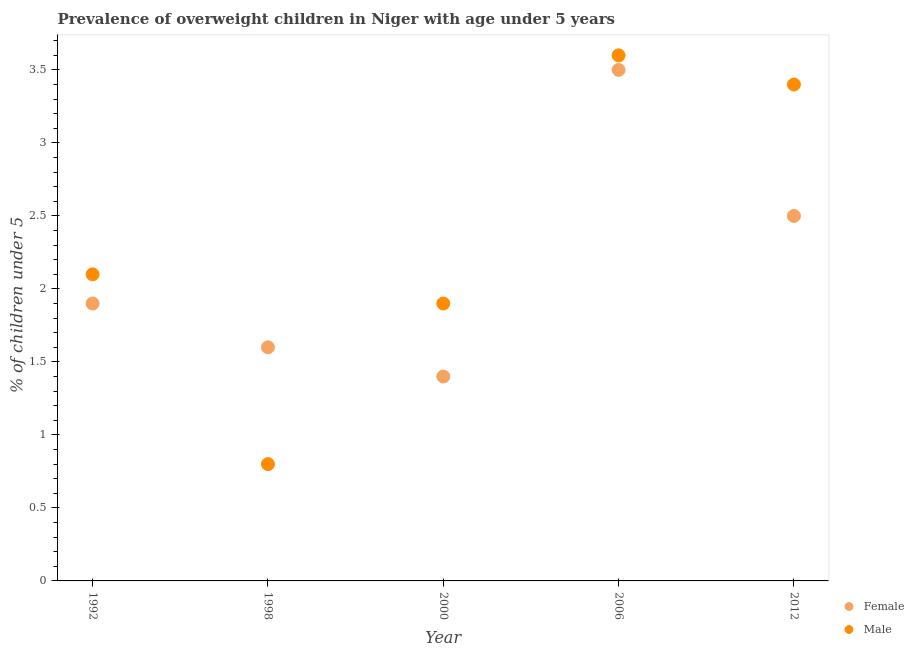Is the number of dotlines equal to the number of legend labels?
Your answer should be very brief. Yes. What is the percentage of obese female children in 1992?
Your answer should be compact. 1.9. Across all years, what is the minimum percentage of obese male children?
Offer a terse response. 0.8. In which year was the percentage of obese male children minimum?
Provide a short and direct response. 1998. What is the total percentage of obese female children in the graph?
Your answer should be very brief. 10.9. What is the difference between the percentage of obese female children in 1992 and that in 2000?
Give a very brief answer. 0.5. What is the difference between the percentage of obese female children in 2006 and the percentage of obese male children in 2000?
Your response must be concise. 1.6. What is the average percentage of obese male children per year?
Offer a terse response. 2.36. In the year 2012, what is the difference between the percentage of obese male children and percentage of obese female children?
Your response must be concise. 0.9. What is the ratio of the percentage of obese female children in 1992 to that in 1998?
Ensure brevity in your answer.  1.19. Is the percentage of obese female children in 1992 less than that in 2006?
Ensure brevity in your answer.  Yes. Is the difference between the percentage of obese female children in 1992 and 1998 greater than the difference between the percentage of obese male children in 1992 and 1998?
Make the answer very short. No. What is the difference between the highest and the second highest percentage of obese male children?
Offer a terse response. 0.2. What is the difference between the highest and the lowest percentage of obese female children?
Make the answer very short. 2.1. Is the percentage of obese female children strictly greater than the percentage of obese male children over the years?
Make the answer very short. No. What is the difference between two consecutive major ticks on the Y-axis?
Your response must be concise. 0.5. Are the values on the major ticks of Y-axis written in scientific E-notation?
Ensure brevity in your answer.  No. How are the legend labels stacked?
Your answer should be very brief. Vertical. What is the title of the graph?
Your answer should be very brief. Prevalence of overweight children in Niger with age under 5 years. Does "Underweight" appear as one of the legend labels in the graph?
Give a very brief answer. No. What is the label or title of the Y-axis?
Provide a short and direct response.  % of children under 5. What is the  % of children under 5 of Female in 1992?
Offer a very short reply. 1.9. What is the  % of children under 5 of Male in 1992?
Your answer should be compact. 2.1. What is the  % of children under 5 in Female in 1998?
Offer a terse response. 1.6. What is the  % of children under 5 in Male in 1998?
Keep it short and to the point. 0.8. What is the  % of children under 5 of Female in 2000?
Provide a succinct answer. 1.4. What is the  % of children under 5 of Male in 2000?
Provide a succinct answer. 1.9. What is the  % of children under 5 of Female in 2006?
Ensure brevity in your answer.  3.5. What is the  % of children under 5 in Male in 2006?
Your answer should be very brief. 3.6. What is the  % of children under 5 of Male in 2012?
Your response must be concise. 3.4. Across all years, what is the maximum  % of children under 5 in Female?
Your answer should be very brief. 3.5. Across all years, what is the maximum  % of children under 5 of Male?
Your answer should be very brief. 3.6. Across all years, what is the minimum  % of children under 5 of Female?
Offer a very short reply. 1.4. Across all years, what is the minimum  % of children under 5 in Male?
Provide a succinct answer. 0.8. What is the total  % of children under 5 in Female in the graph?
Provide a short and direct response. 10.9. What is the total  % of children under 5 of Male in the graph?
Provide a short and direct response. 11.8. What is the difference between the  % of children under 5 in Male in 1992 and that in 1998?
Your answer should be very brief. 1.3. What is the difference between the  % of children under 5 in Female in 1992 and that in 2000?
Your answer should be very brief. 0.5. What is the difference between the  % of children under 5 in Male in 1992 and that in 2000?
Offer a terse response. 0.2. What is the difference between the  % of children under 5 of Female in 1992 and that in 2006?
Your answer should be compact. -1.6. What is the difference between the  % of children under 5 of Female in 1992 and that in 2012?
Your answer should be very brief. -0.6. What is the difference between the  % of children under 5 in Female in 1998 and that in 2000?
Your response must be concise. 0.2. What is the difference between the  % of children under 5 in Male in 1998 and that in 2000?
Keep it short and to the point. -1.1. What is the difference between the  % of children under 5 of Female in 1998 and that in 2006?
Your answer should be compact. -1.9. What is the difference between the  % of children under 5 of Male in 2000 and that in 2006?
Your answer should be compact. -1.7. What is the difference between the  % of children under 5 in Female in 2006 and that in 2012?
Make the answer very short. 1. What is the difference between the  % of children under 5 in Male in 2006 and that in 2012?
Provide a short and direct response. 0.2. What is the difference between the  % of children under 5 in Female in 1992 and the  % of children under 5 in Male in 2000?
Your answer should be compact. 0. What is the difference between the  % of children under 5 of Female in 1992 and the  % of children under 5 of Male in 2006?
Offer a terse response. -1.7. What is the difference between the  % of children under 5 of Female in 1998 and the  % of children under 5 of Male in 2000?
Your answer should be compact. -0.3. What is the difference between the  % of children under 5 of Female in 1998 and the  % of children under 5 of Male in 2006?
Your response must be concise. -2. What is the difference between the  % of children under 5 of Female in 1998 and the  % of children under 5 of Male in 2012?
Provide a short and direct response. -1.8. What is the difference between the  % of children under 5 of Female in 2000 and the  % of children under 5 of Male in 2006?
Provide a succinct answer. -2.2. What is the average  % of children under 5 in Female per year?
Provide a succinct answer. 2.18. What is the average  % of children under 5 in Male per year?
Provide a short and direct response. 2.36. In the year 1992, what is the difference between the  % of children under 5 of Female and  % of children under 5 of Male?
Your response must be concise. -0.2. In the year 2006, what is the difference between the  % of children under 5 in Female and  % of children under 5 in Male?
Provide a succinct answer. -0.1. What is the ratio of the  % of children under 5 of Female in 1992 to that in 1998?
Give a very brief answer. 1.19. What is the ratio of the  % of children under 5 of Male in 1992 to that in 1998?
Your response must be concise. 2.62. What is the ratio of the  % of children under 5 in Female in 1992 to that in 2000?
Provide a succinct answer. 1.36. What is the ratio of the  % of children under 5 of Male in 1992 to that in 2000?
Offer a very short reply. 1.11. What is the ratio of the  % of children under 5 in Female in 1992 to that in 2006?
Give a very brief answer. 0.54. What is the ratio of the  % of children under 5 of Male in 1992 to that in 2006?
Your answer should be very brief. 0.58. What is the ratio of the  % of children under 5 of Female in 1992 to that in 2012?
Provide a short and direct response. 0.76. What is the ratio of the  % of children under 5 in Male in 1992 to that in 2012?
Your answer should be compact. 0.62. What is the ratio of the  % of children under 5 in Male in 1998 to that in 2000?
Offer a very short reply. 0.42. What is the ratio of the  % of children under 5 of Female in 1998 to that in 2006?
Ensure brevity in your answer.  0.46. What is the ratio of the  % of children under 5 in Male in 1998 to that in 2006?
Make the answer very short. 0.22. What is the ratio of the  % of children under 5 of Female in 1998 to that in 2012?
Make the answer very short. 0.64. What is the ratio of the  % of children under 5 of Male in 1998 to that in 2012?
Your answer should be compact. 0.24. What is the ratio of the  % of children under 5 of Male in 2000 to that in 2006?
Offer a terse response. 0.53. What is the ratio of the  % of children under 5 in Female in 2000 to that in 2012?
Your answer should be compact. 0.56. What is the ratio of the  % of children under 5 of Male in 2000 to that in 2012?
Keep it short and to the point. 0.56. What is the ratio of the  % of children under 5 in Female in 2006 to that in 2012?
Offer a very short reply. 1.4. What is the ratio of the  % of children under 5 in Male in 2006 to that in 2012?
Make the answer very short. 1.06. What is the difference between the highest and the second highest  % of children under 5 in Female?
Ensure brevity in your answer.  1. What is the difference between the highest and the second highest  % of children under 5 in Male?
Provide a succinct answer. 0.2. What is the difference between the highest and the lowest  % of children under 5 in Female?
Ensure brevity in your answer.  2.1. What is the difference between the highest and the lowest  % of children under 5 in Male?
Keep it short and to the point. 2.8. 